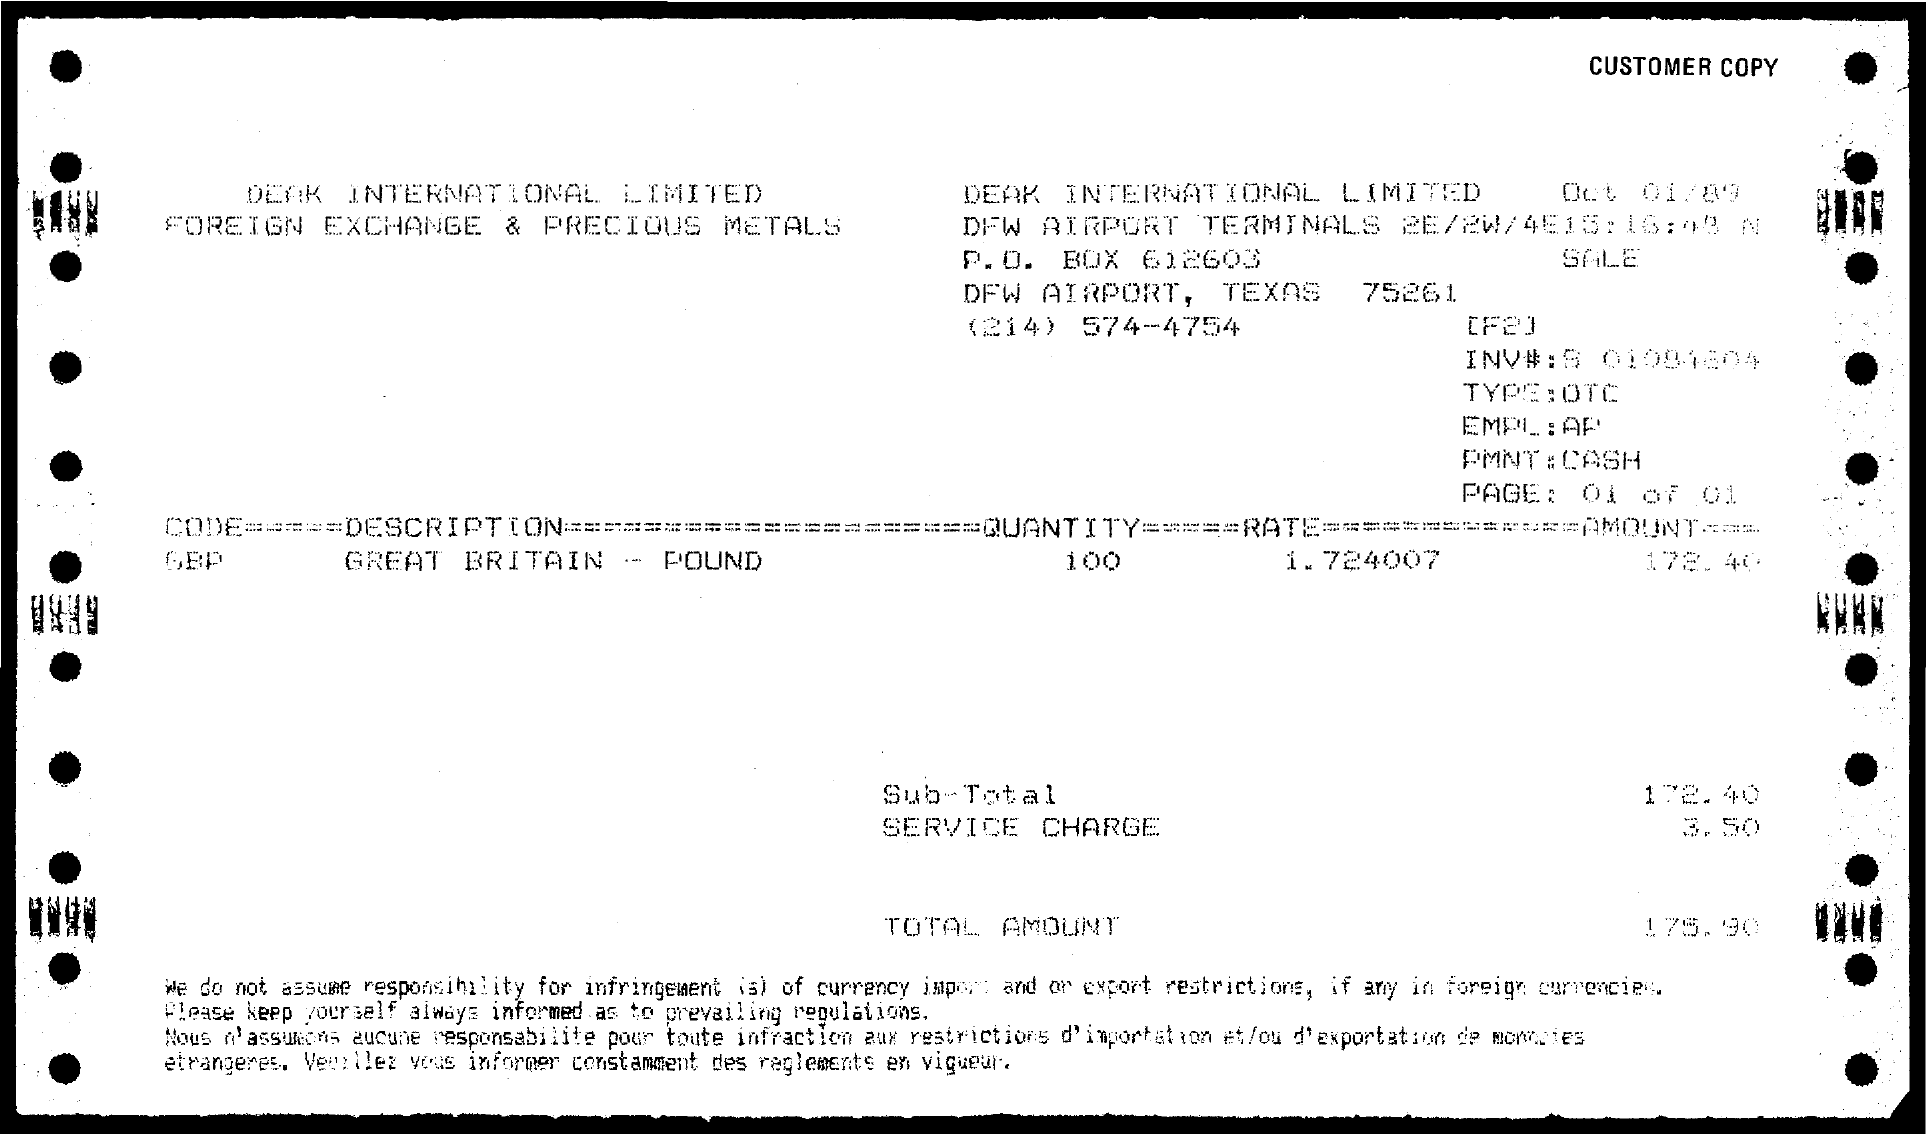What is the Type?
Provide a short and direct response. OTC. What is the EMPL:?
Give a very brief answer. AP. What is the PMNT:?
Make the answer very short. CASH. What is the Description?
Make the answer very short. Great Britain - Pound. What is the Quantity?
Offer a very short reply. 100. What is the Rate?
Keep it short and to the point. 1 724007. What is the Sub-Total?
Provide a short and direct response. 172 40. What is the service charge?
Provide a short and direct response. 3.50. What is the Total amount?
Ensure brevity in your answer.  175 90. 